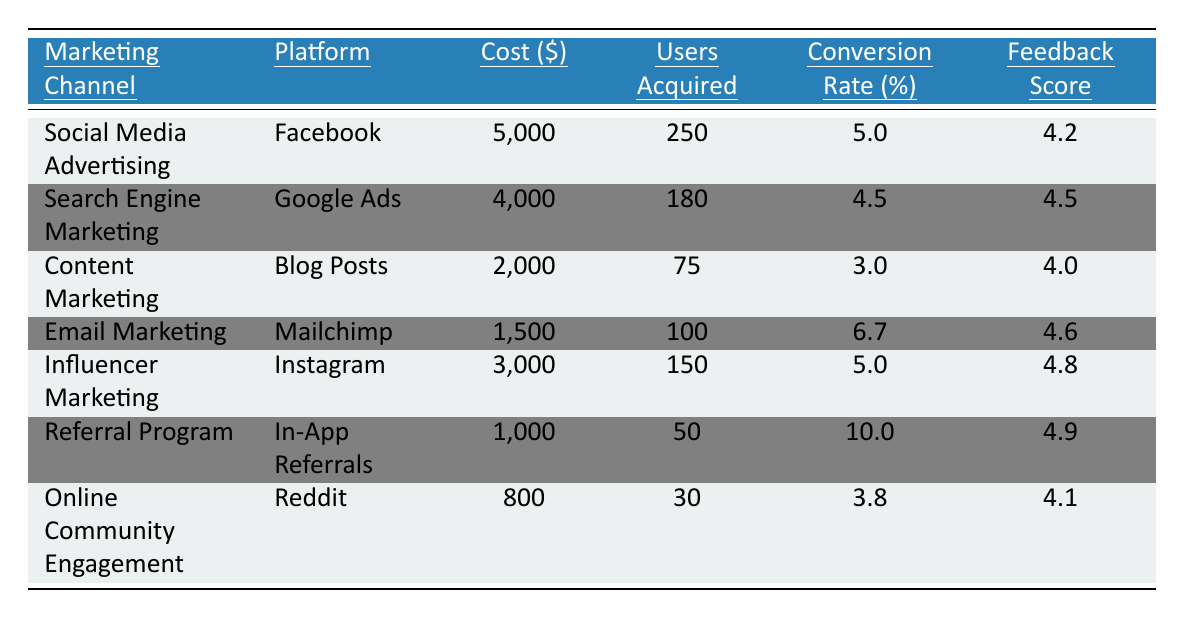What is the marketing channel with the highest cost? The cost figures are listed in the table, and the channel with the highest cost is Social Media Advertising at $5,000.
Answer: Social Media Advertising Which marketing channel acquired the most users? The "Users Acquired" column shows that Social Media Advertising acquired the most users, totaling 250.
Answer: Social Media Advertising What is the conversion rate of Email Marketing? The "Conversion Rate" for Email Marketing is explicitly stated as 6.7%.
Answer: 6.7% What is the feedback score for the Referral Program? The table indicates that the feedback score for the Referral Program is 4.9.
Answer: 4.9 How much did the Online Community Engagement cost? The cost of Online Community Engagement is listed as $800.
Answer: $800 What is the average conversion rate across all marketing channels? The conversion rates from each channel are 5.0, 4.5, 3.0, 6.7, 5.0, 10.0, and 3.8. Adding these gives 33.0, and dividing by the number of channels (7) results in an average of 4.71.
Answer: 4.71 Which marketing channel had the highest feedback score? The feedback scores from the channels are compared and it is found that the Referral Program has the highest score at 4.9.
Answer: Referral Program What is the total cost spent on all marketing channels? The costs are $5,000 + $4,000 + $2,000 + $1,500 + $3,000 + $1,000 + $800, which totals $17,300.
Answer: $17,300 Which channel has a conversion rate greater than 5%? From the table, the channels with a conversion rate greater than 5% are Email Marketing (6.7%) and Referral Program (10.0%).
Answer: Email Marketing, Referral Program What is the difference in users acquired between Social Media Advertising and Content Marketing? Social Media Advertising acquired 250 users, and Content Marketing acquired 75 users. The difference is 250 - 75 = 175 users.
Answer: 175 users What is the total number of users acquired from all marketing channels? Adding the users acquired from each channel totals 250 + 180 + 75 + 100 + 150 + 50 + 30 = 835 users.
Answer: 835 users Is the feedback score for Influencer Marketing higher than that for Email Marketing? Influencer Marketing has a score of 4.8 and Email Marketing has 4.6. Since 4.8 > 4.6, the statement is true.
Answer: Yes What is the average number of users acquired per dollar spent across all marketing channels? To find this, calculate the total users acquired (835) divided by the total cost ($17,300), resulting in an average of approximately 0.0482 users per dollar.
Answer: 0.0482 users per dollar 